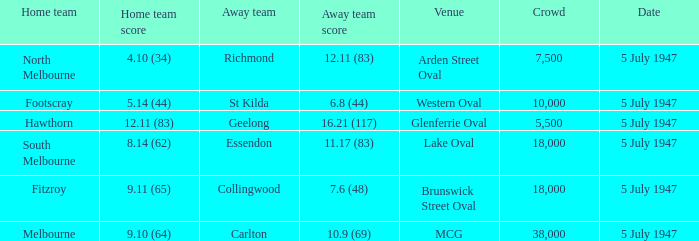In which venue did the away team achieve a score of 7.6 (48)? Brunswick Street Oval. 